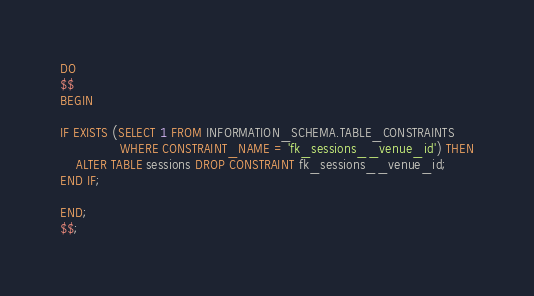Convert code to text. <code><loc_0><loc_0><loc_500><loc_500><_SQL_>DO
$$
BEGIN

IF EXISTS (SELECT 1 FROM INFORMATION_SCHEMA.TABLE_CONSTRAINTS
               WHERE CONSTRAINT_NAME = 'fk_sessions__venue_id') THEN
    ALTER TABLE sessions DROP CONSTRAINT fk_sessions__venue_id;
END IF;

END;
$$;</code> 